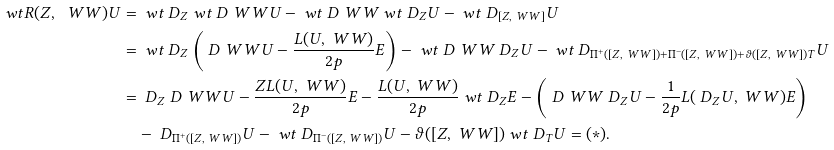<formula> <loc_0><loc_0><loc_500><loc_500>\ w t R ( Z , \ W W ) U & = \ w t \ D _ { Z } \ w t \ D _ { \ } W W U - \ w t \ D _ { \ } W W \ w t \ D _ { Z } U - \ w t \ D _ { [ Z , \ W W ] } U \\ & = \ w t \ D _ { Z } \left ( \ D _ { \ } W W U - \frac { L ( U , \ W W ) } { 2 p } E \right ) - \ w t \ D _ { \ } W W \ D _ { Z } U - \ w t \ D _ { \Pi ^ { + } ( [ Z , \ W W ] ) + \Pi ^ { - } ( [ Z , \ W W ] ) + \vartheta ( [ Z , \ W W ] ) T } U \\ & = \ D _ { Z } \ D _ { \ } W W U - \frac { Z L ( U , \ W W ) } { 2 p } E - \frac { L ( U , \ W W ) } { 2 p } \ w t \ D _ { Z } E - \left ( \ D _ { \ } W W \ D _ { Z } U - \frac { 1 } { 2 p } L ( \ D _ { Z } U , \ W W ) E \right ) \\ & \quad - \ D _ { \Pi ^ { + } ( [ Z , \ W W ] ) } U - \ w t \ D _ { \Pi ^ { - } ( [ Z , \ W W ] ) } U - \vartheta ( [ Z , \ W W ] ) \ w t \ D _ { T } U = ( * ) .</formula> 